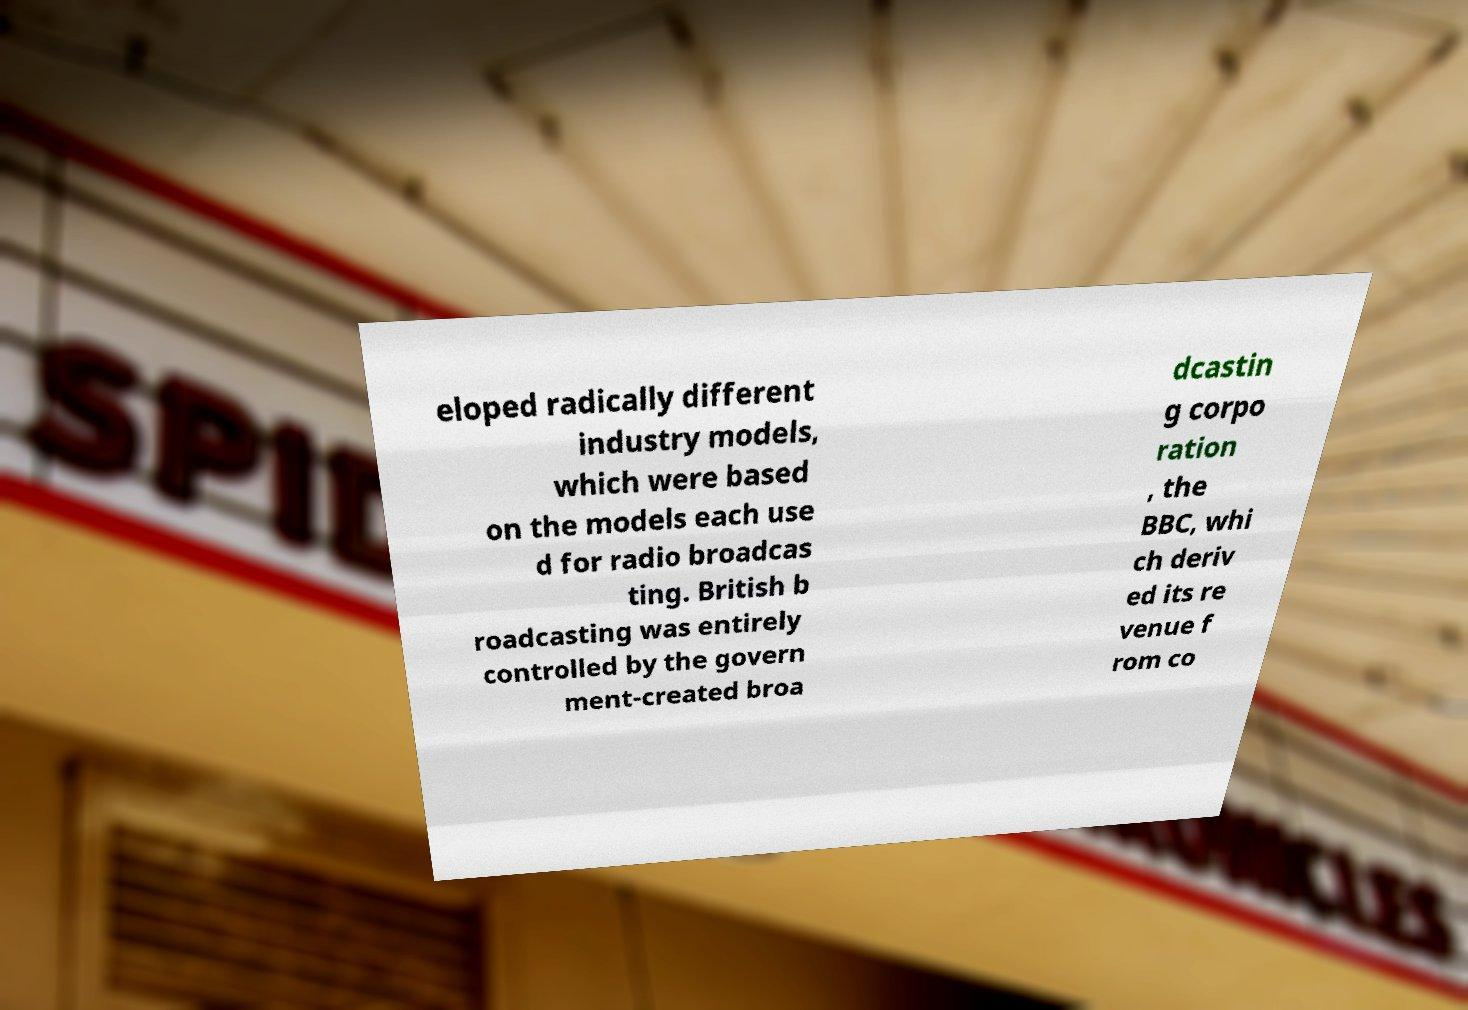Could you assist in decoding the text presented in this image and type it out clearly? eloped radically different industry models, which were based on the models each use d for radio broadcas ting. British b roadcasting was entirely controlled by the govern ment-created broa dcastin g corpo ration , the BBC, whi ch deriv ed its re venue f rom co 